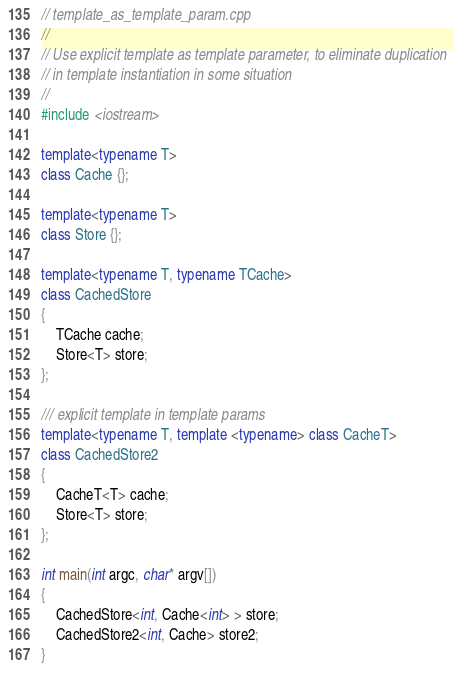Convert code to text. <code><loc_0><loc_0><loc_500><loc_500><_C++_>// template_as_template_param.cpp
//
// Use explicit template as template parameter, to eliminate duplication
// in template instantiation in some situation
//
#include <iostream>

template<typename T>
class Cache {};

template<typename T>
class Store {};

template<typename T, typename TCache>
class CachedStore
{
    TCache cache;
    Store<T> store;
};

/// explicit template in template params
template<typename T, template <typename> class CacheT>
class CachedStore2
{
    CacheT<T> cache;
    Store<T> store;
};

int main(int argc, char* argv[])
{
    CachedStore<int, Cache<int> > store;
    CachedStore2<int, Cache> store2;
}
</code> 